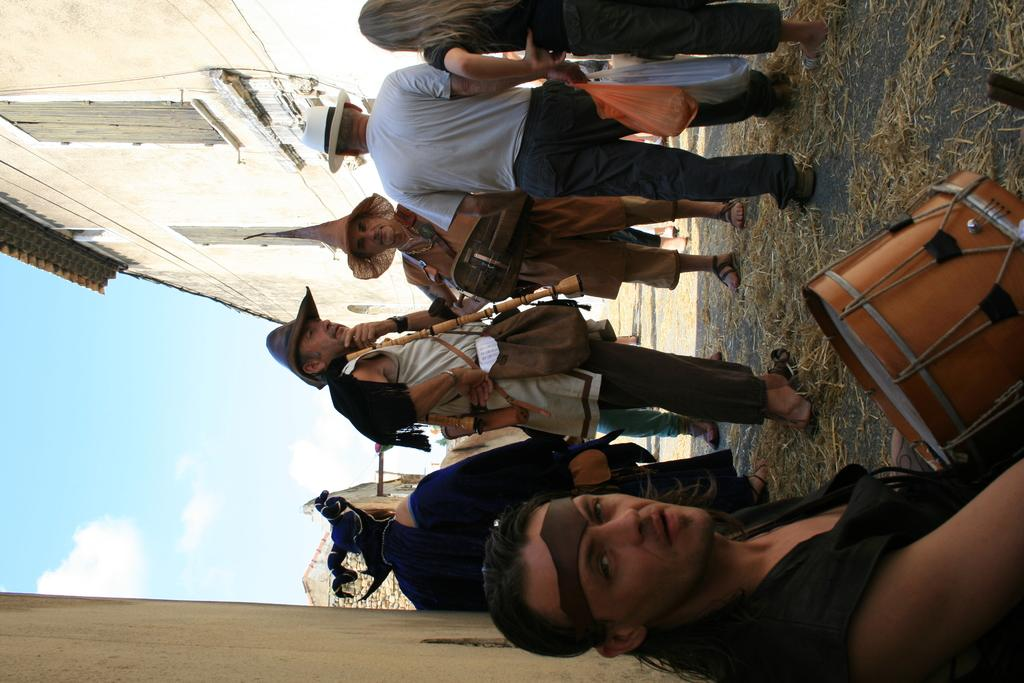Who or what can be seen in the image? There are people in the image. Where are the people located? The people are standing in a street. What are the people doing in the image? The people are holding musical instruments. What type of wren can be seen perched on the musical instruments in the image? There is no wren present in the image; the people are holding the musical instruments themselves. 